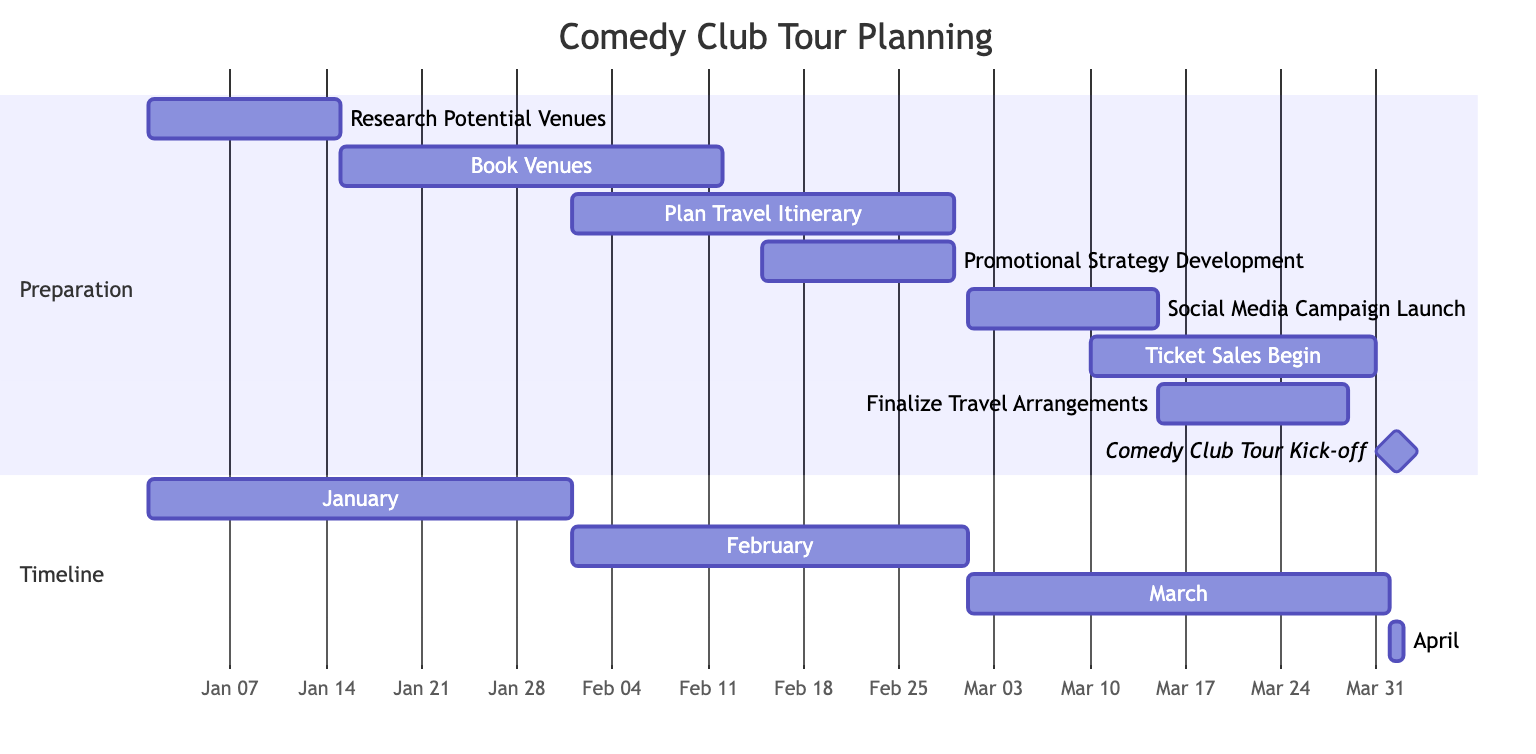What's the duration of the "Research Potential Venues" task? The diagram shows the "Research Potential Venues" task spans from January 1 to January 14, which is 2 weeks in duration as indicated in the Gantt chart.
Answer: 2 weeks When does the "Ticket Sales Begin" task start? The diagram clearly marks the "Ticket Sales Begin" task, which starts on March 10, and continues until March 31.
Answer: March 10 Which task overlaps with "Promotional Strategy Development"? Analyzing the timeline, the "Promotional Strategy Development" spans from February 15 to March 1, overlapping with the "Book Venues" task from January 15 to February 15 and the "Social Media Campaign Launch" from March 1 to March 15.
Answer: Social Media Campaign Launch How many total tasks are laid out in the Gantt chart? Counting the individual tasks in the preparation section and the kick-off milestone, there are 8 tasks in total.
Answer: 8 What's the end date of the "Plan Travel Itinerary" task? In the diagram, the "Plan Travel Itinerary" starts on February 1 and concludes on February 28, as shown in the timeline.
Answer: February 28 Which task has the longest individual duration? Reviewing the tasks, "Book Venues" has a duration of 4 weeks, which is longer than any other task in the Gantt chart.
Answer: 4 weeks On what date does the comedy club tour officially start? The diagram highlights the milestone "Comedy Club Tour Kick-off," which is scheduled for April 1, making this the start date.
Answer: April 1 How many weeks is allocated for the "Finalize Travel Arrangements"? In the diagram, "Finalize Travel Arrangements" is assigned a duration of 2 weeks, as indicated by the start and end dates.
Answer: 2 weeks 